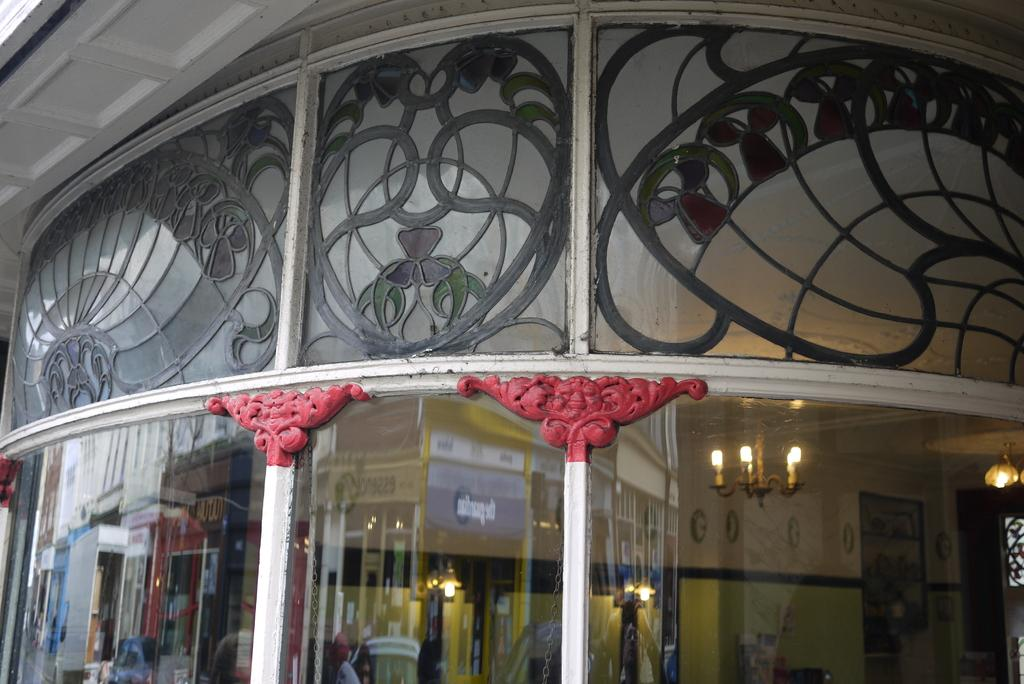What type of structure is visible in the image? There is a building in the image. What type of glove is being worn by the building in the image? There is no glove present in the image; it is a building. 